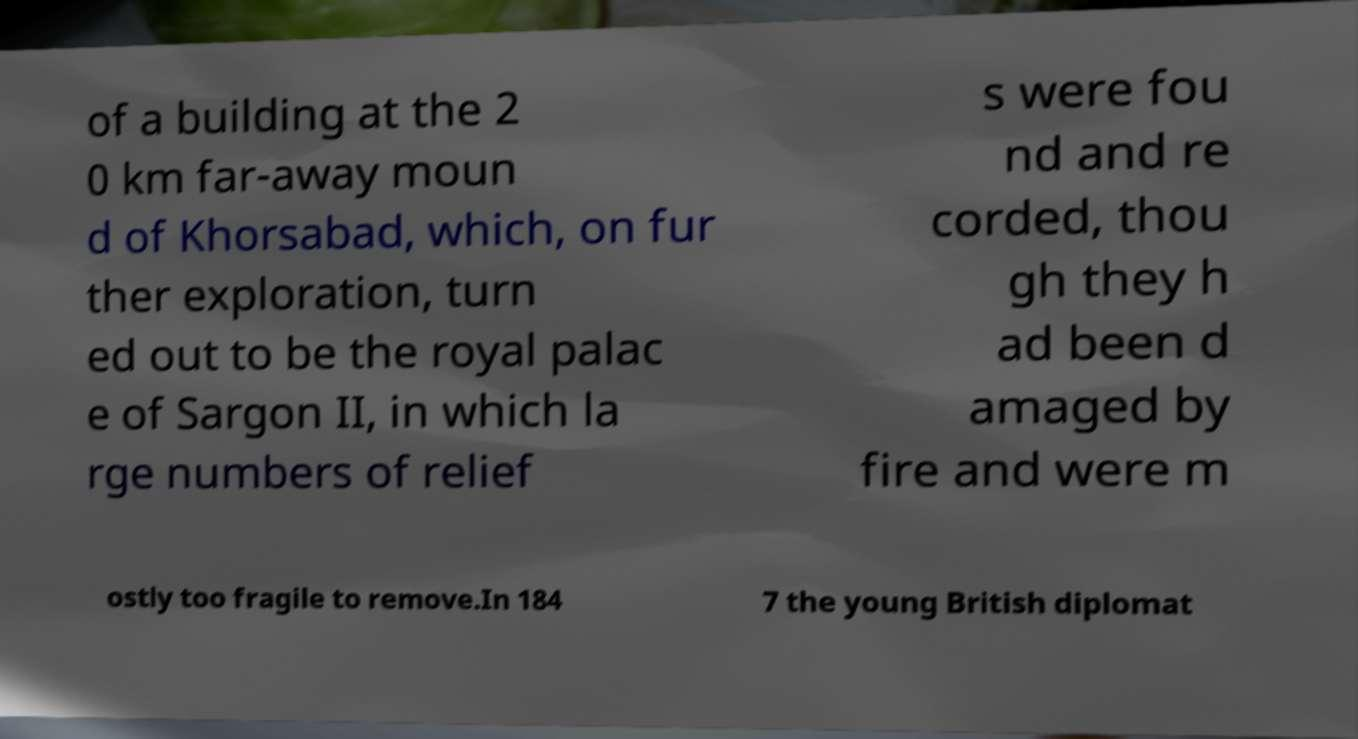There's text embedded in this image that I need extracted. Can you transcribe it verbatim? of a building at the 2 0 km far-away moun d of Khorsabad, which, on fur ther exploration, turn ed out to be the royal palac e of Sargon II, in which la rge numbers of relief s were fou nd and re corded, thou gh they h ad been d amaged by fire and were m ostly too fragile to remove.In 184 7 the young British diplomat 